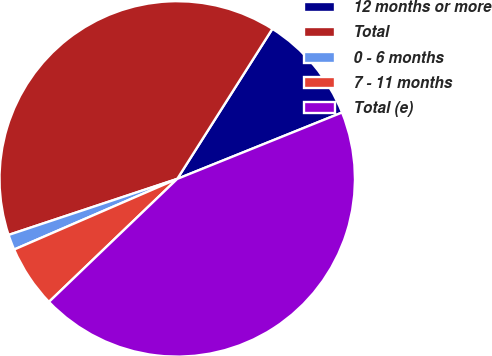Convert chart. <chart><loc_0><loc_0><loc_500><loc_500><pie_chart><fcel>12 months or more<fcel>Total<fcel>0 - 6 months<fcel>7 - 11 months<fcel>Total (e)<nl><fcel>9.91%<fcel>39.1%<fcel>1.4%<fcel>5.66%<fcel>43.93%<nl></chart> 